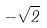Convert formula to latex. <formula><loc_0><loc_0><loc_500><loc_500>- \sqrt { 2 }</formula> 